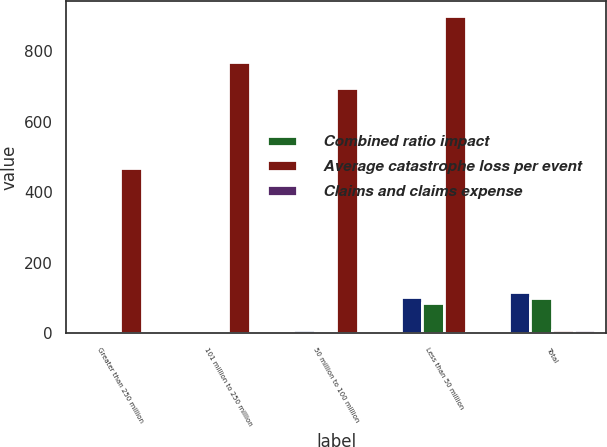Convert chart to OTSL. <chart><loc_0><loc_0><loc_500><loc_500><stacked_bar_chart><ecel><fcel>Greater than 250 million<fcel>101 million to 250 million<fcel>50 million to 100 million<fcel>Less than 50 million<fcel>Total<nl><fcel>nan<fcel>1<fcel>5<fcel>9<fcel>102<fcel>117<nl><fcel>Combined ratio impact<fcel>0.8<fcel>4.3<fcel>7.7<fcel>87.2<fcel>100<nl><fcel>Average catastrophe loss per event<fcel>469<fcel>769<fcel>694<fcel>898<fcel>8.6<nl><fcel>Claims and claims expense<fcel>1.4<fcel>2.3<fcel>2.1<fcel>2.8<fcel>8.6<nl></chart> 